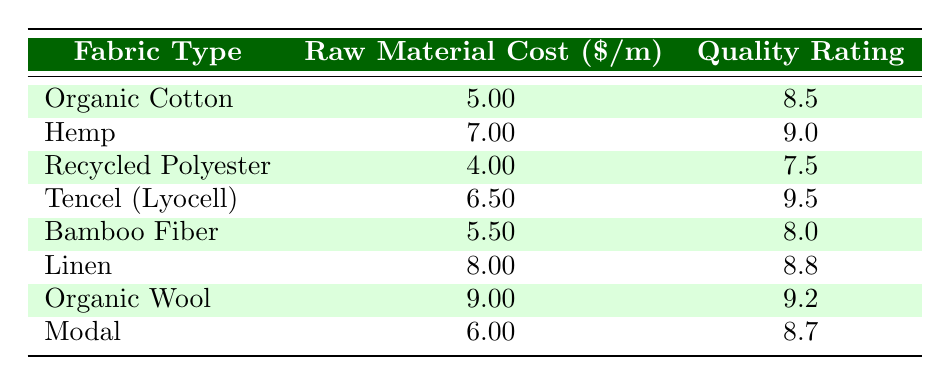What is the raw material cost per meter for Organic Cotton? The table lists Organic Cotton and shows a corresponding value in the "Raw Material Cost" column, which is 5.00.
Answer: 5.00 Which fabric has the highest product quality rating? By comparing the "Product Quality Rating" values in the table, the highest rating is 9.5 for Tencel (Lyocell).
Answer: Tencel (Lyocell) What is the average raw material cost of all fabrics listed? Adding the raw material costs: (5.00 + 7.00 + 4.00 + 6.50 + 5.50 + 8.00 + 9.00 + 6.00) = 51.00, and there are 8 fabrics, so the average cost is 51.00 / 8 = 6.375.
Answer: 6.375 Is the product quality rating for Recycled Polyester greater than 7.5? The table shows that the product quality rating for Recycled Polyester is exactly 7.5, so it is not greater.
Answer: No What is the difference in product quality ratings between the highest and lowest rated fabrics? The highest rating is from Tencel (9.5) and the lowest rating is from Recycled Polyester (7.5). The difference is 9.5 - 7.5 = 2.0.
Answer: 2.0 Do most of the fabrics have a raw material cost of over 6 dollars per meter? There are 8 fabrics listed, and three of them (Hemp, Linen, Organic Wool) have costs over 6 dollars, which is less than half.
Answer: No What raw material cost is associated with the fabric that has a product quality rating of 9.2? Looking at the table, the fabric with a product rating of 9.2 is Organic Wool, which has a corresponding raw material cost of 9.00.
Answer: 9.00 If we consider only the fabrics costing less than 6 dollars, what is the average quality rating? The fabrics with costs below 6 dollars are Organic Cotton (8.5), Recycled Polyester (7.5), and Bamboo Fiber (8.0). Their average quality rating is (8.5 + 7.5 + 8.0) / 3 = 8.0.
Answer: 8.0 